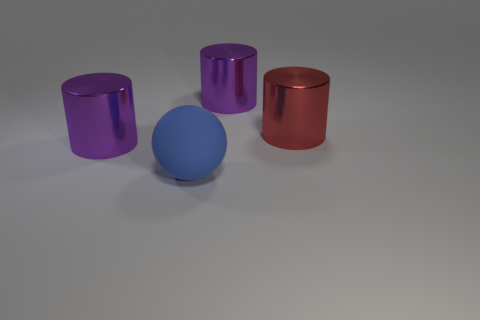Is the number of big red objects that are in front of the large red metallic object the same as the number of large rubber things in front of the blue rubber ball?
Your answer should be very brief. Yes. There is a purple metallic cylinder that is in front of the red cylinder; are there any objects that are behind it?
Offer a terse response. Yes. There is a purple metallic object that is on the right side of the metallic cylinder that is on the left side of the big ball; what number of purple metallic objects are in front of it?
Your answer should be very brief. 1. Is the number of blue rubber objects less than the number of big metallic cylinders?
Offer a very short reply. Yes. Does the big purple metal thing that is behind the big red cylinder have the same shape as the big purple shiny thing on the left side of the big rubber ball?
Your answer should be very brief. Yes. The big matte thing is what color?
Ensure brevity in your answer.  Blue. What number of shiny things are either purple objects or big blue objects?
Your response must be concise. 2. Are there any big metallic cylinders?
Your answer should be compact. Yes. Do the large purple cylinder to the right of the matte thing and the red cylinder on the right side of the sphere have the same material?
Your answer should be very brief. Yes. What number of objects are either cylinders that are on the left side of the big matte ball or shiny things behind the red object?
Offer a terse response. 2. 